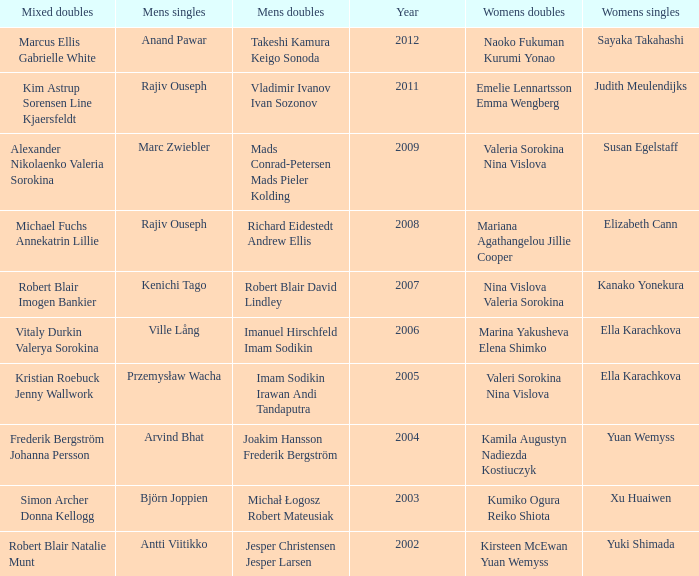Name the men's singles of marina yakusheva elena shimko Ville Lång. 